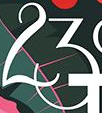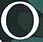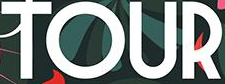What text appears in these images from left to right, separated by a semicolon? 23; °; TOUR 